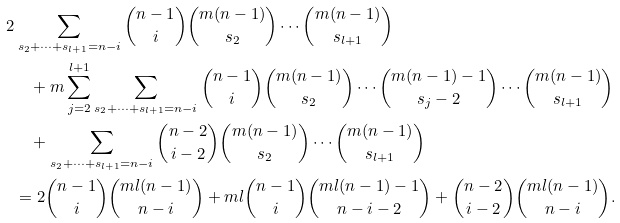Convert formula to latex. <formula><loc_0><loc_0><loc_500><loc_500>2 & \sum _ { s _ { 2 } + \dots + s _ { l + 1 } = n - i } \binom { n - 1 } { i } \binom { m ( n - 1 ) } { s _ { 2 } } \cdots \binom { m ( n - 1 ) } { s _ { l + 1 } } \\ & \quad + m \sum _ { j = 2 } ^ { l + 1 } \sum _ { s _ { 2 } + \dots + s _ { l + 1 } = n - i } \binom { n - 1 } { i } \binom { m ( n - 1 ) } { s _ { 2 } } \cdots \binom { m ( n - 1 ) - 1 } { s _ { j } - 2 } \cdots \binom { m ( n - 1 ) } { s _ { l + 1 } } \\ & \quad + \sum _ { s _ { 2 } + \dots + s _ { l + 1 } = n - i } \binom { n - 2 } { i - 2 } \binom { m ( n - 1 ) } { s _ { 2 } } \cdots \binom { m ( n - 1 ) } { s _ { l + 1 } } \\ & = 2 \binom { n - 1 } { i } \binom { m l ( n - 1 ) } { n - i } + m l \binom { n - 1 } { i } \binom { m l ( n - 1 ) - 1 } { n - i - 2 } + \binom { n - 2 } { i - 2 } \binom { m l ( n - 1 ) } { n - i } .</formula> 